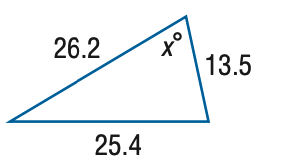Question: Find x. Round the angle measure to the nearest degree.
Choices:
A. 68
B. 72
C. 76
D. 80
Answer with the letter. Answer: B 